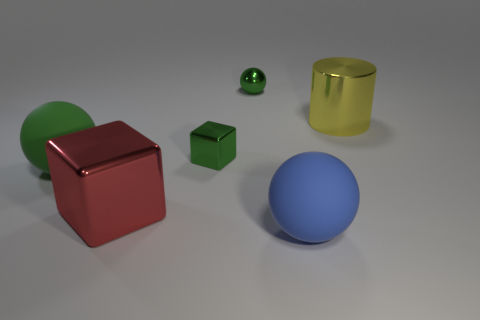Add 1 tiny green metallic cubes. How many objects exist? 7 Subtract all cylinders. How many objects are left? 5 Subtract 0 yellow blocks. How many objects are left? 6 Subtract all small green metal cubes. Subtract all large shiny things. How many objects are left? 3 Add 1 large green rubber objects. How many large green rubber objects are left? 2 Add 5 big metallic cylinders. How many big metallic cylinders exist? 6 